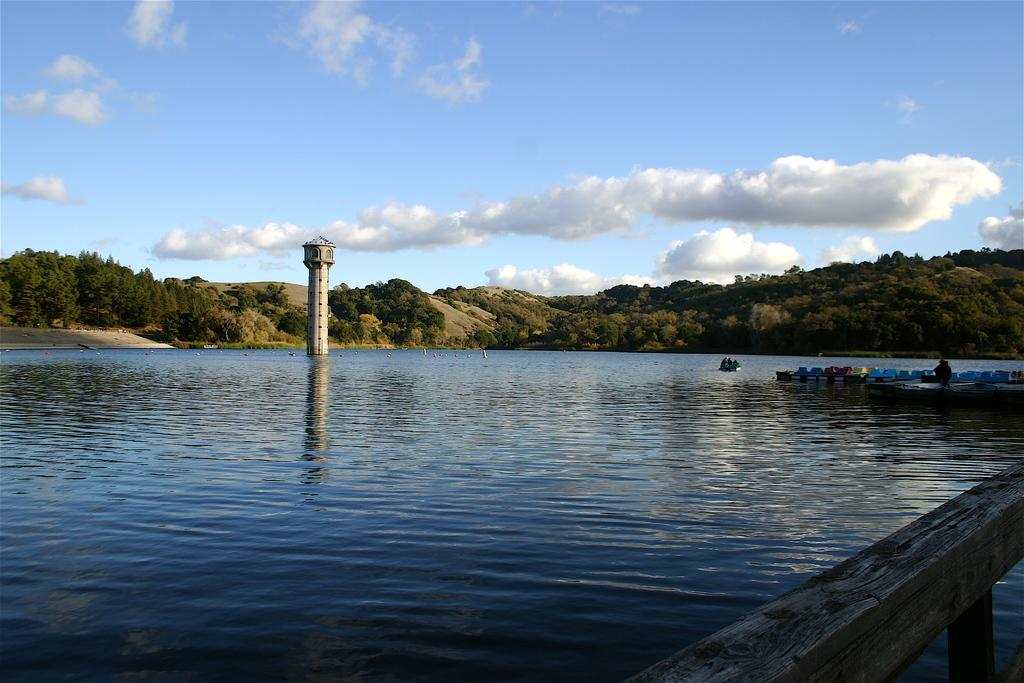What body of water is present in the image? There is a river in the image. What structure is located near the river? There is a bridge beside the river. What unique feature can be seen in the river? There is a tall tower in the river. What type of vegetation is visible in the background of the image? There are many trees in the background of the image. What type of camp can be seen near the tall tower in the river? There is no camp present in the image; it only features a river, a bridge, a tall tower, and trees in the background. 